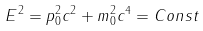Convert formula to latex. <formula><loc_0><loc_0><loc_500><loc_500>E ^ { 2 } = p _ { 0 } ^ { 2 } c ^ { 2 } + m _ { 0 } ^ { 2 } c ^ { 4 } = C o n s t</formula> 